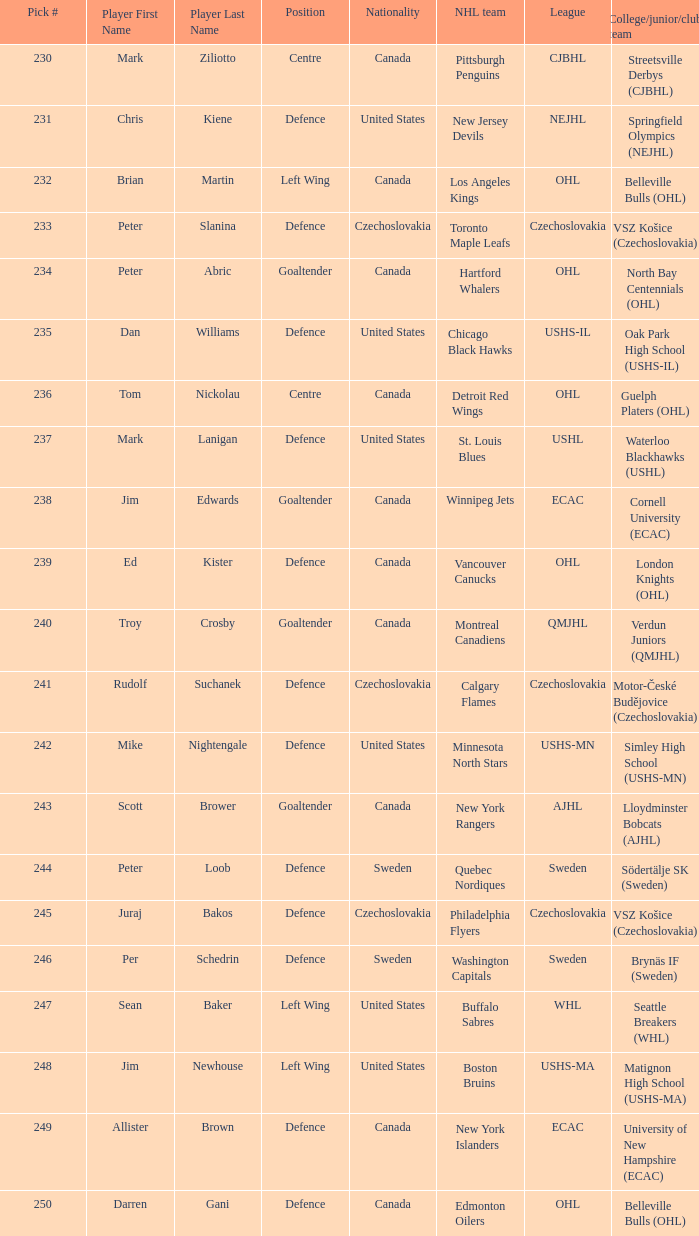In the context of nejhl, what was the springfield olympics option? 231.0. 